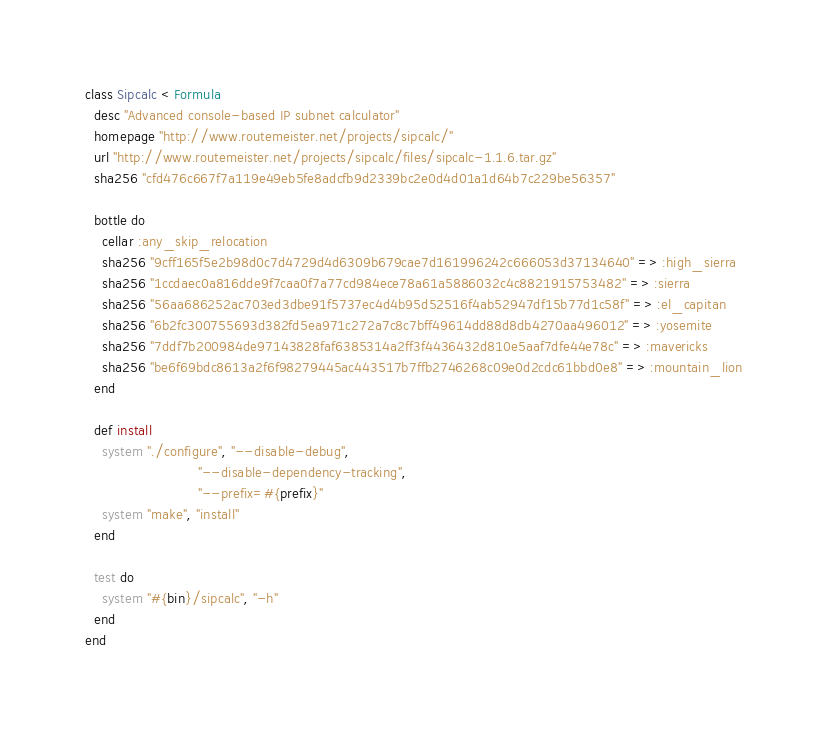Convert code to text. <code><loc_0><loc_0><loc_500><loc_500><_Ruby_>class Sipcalc < Formula
  desc "Advanced console-based IP subnet calculator"
  homepage "http://www.routemeister.net/projects/sipcalc/"
  url "http://www.routemeister.net/projects/sipcalc/files/sipcalc-1.1.6.tar.gz"
  sha256 "cfd476c667f7a119e49eb5fe8adcfb9d2339bc2e0d4d01a1d64b7c229be56357"

  bottle do
    cellar :any_skip_relocation
    sha256 "9cff165f5e2b98d0c7d4729d4d6309b679cae7d161996242c666053d37134640" => :high_sierra
    sha256 "1ccdaec0a816dde9f7caa0f7a77cd984ece78a61a5886032c4c8821915753482" => :sierra
    sha256 "56aa686252ac703ed3dbe91f5737ec4d4b95d52516f4ab52947df15b77d1c58f" => :el_capitan
    sha256 "6b2fc300755693d382fd5ea971c272a7c8c7bff49614dd88d8db4270aa496012" => :yosemite
    sha256 "7ddf7b200984de97143828faf6385314a2ff3f4436432d810e5aaf7dfe44e78c" => :mavericks
    sha256 "be6f69bdc8613a2f6f98279445ac443517b7ffb2746268c09e0d2cdc61bbd0e8" => :mountain_lion
  end

  def install
    system "./configure", "--disable-debug",
                          "--disable-dependency-tracking",
                          "--prefix=#{prefix}"
    system "make", "install"
  end

  test do
    system "#{bin}/sipcalc", "-h"
  end
end
</code> 